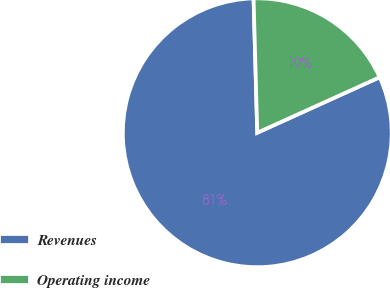Convert chart to OTSL. <chart><loc_0><loc_0><loc_500><loc_500><pie_chart><fcel>Revenues<fcel>Operating income<nl><fcel>81.34%<fcel>18.66%<nl></chart> 